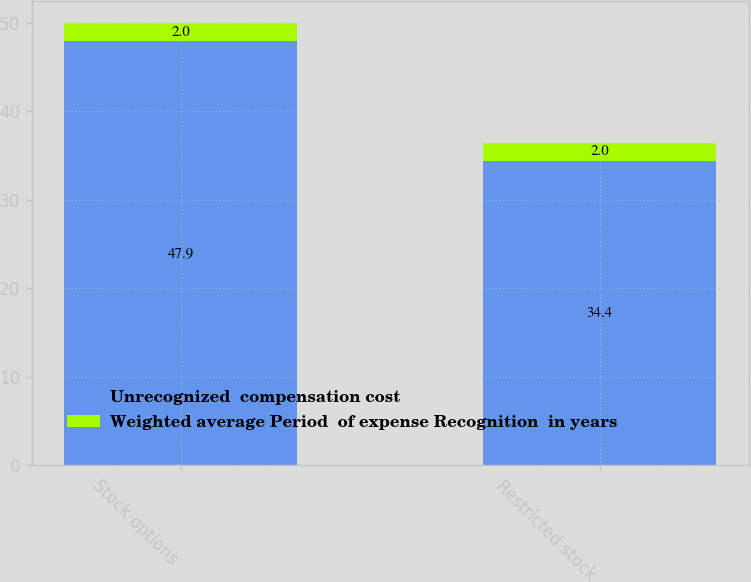Convert chart. <chart><loc_0><loc_0><loc_500><loc_500><stacked_bar_chart><ecel><fcel>Stock options<fcel>Restricted stock<nl><fcel>Unrecognized  compensation cost<fcel>47.9<fcel>34.4<nl><fcel>Weighted average Period  of expense Recognition  in years<fcel>2<fcel>2<nl></chart> 